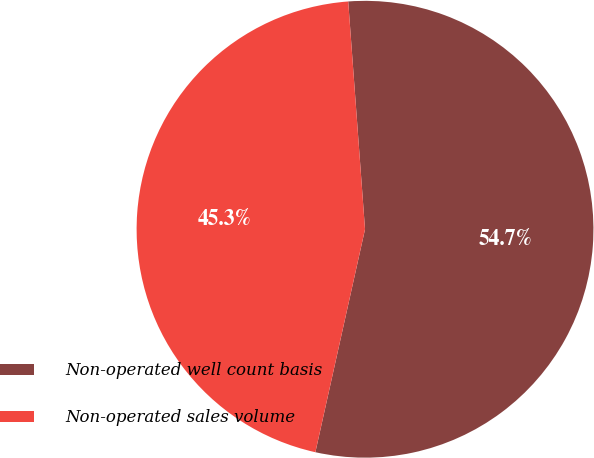Convert chart. <chart><loc_0><loc_0><loc_500><loc_500><pie_chart><fcel>Non-operated well count basis<fcel>Non-operated sales volume<nl><fcel>54.66%<fcel>45.34%<nl></chart> 